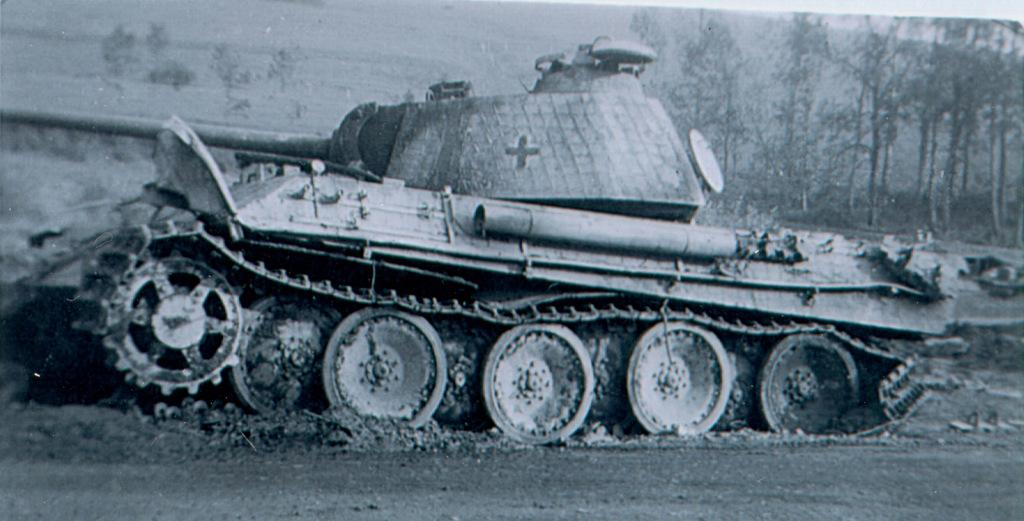What is the main subject in the image? There is a vehicle in the image. Can you describe the background of the image? There are trees in the background of the image. What type of dock can be seen near the vehicle in the image? There is no dock present in the image; it only features a vehicle and trees in the background. 